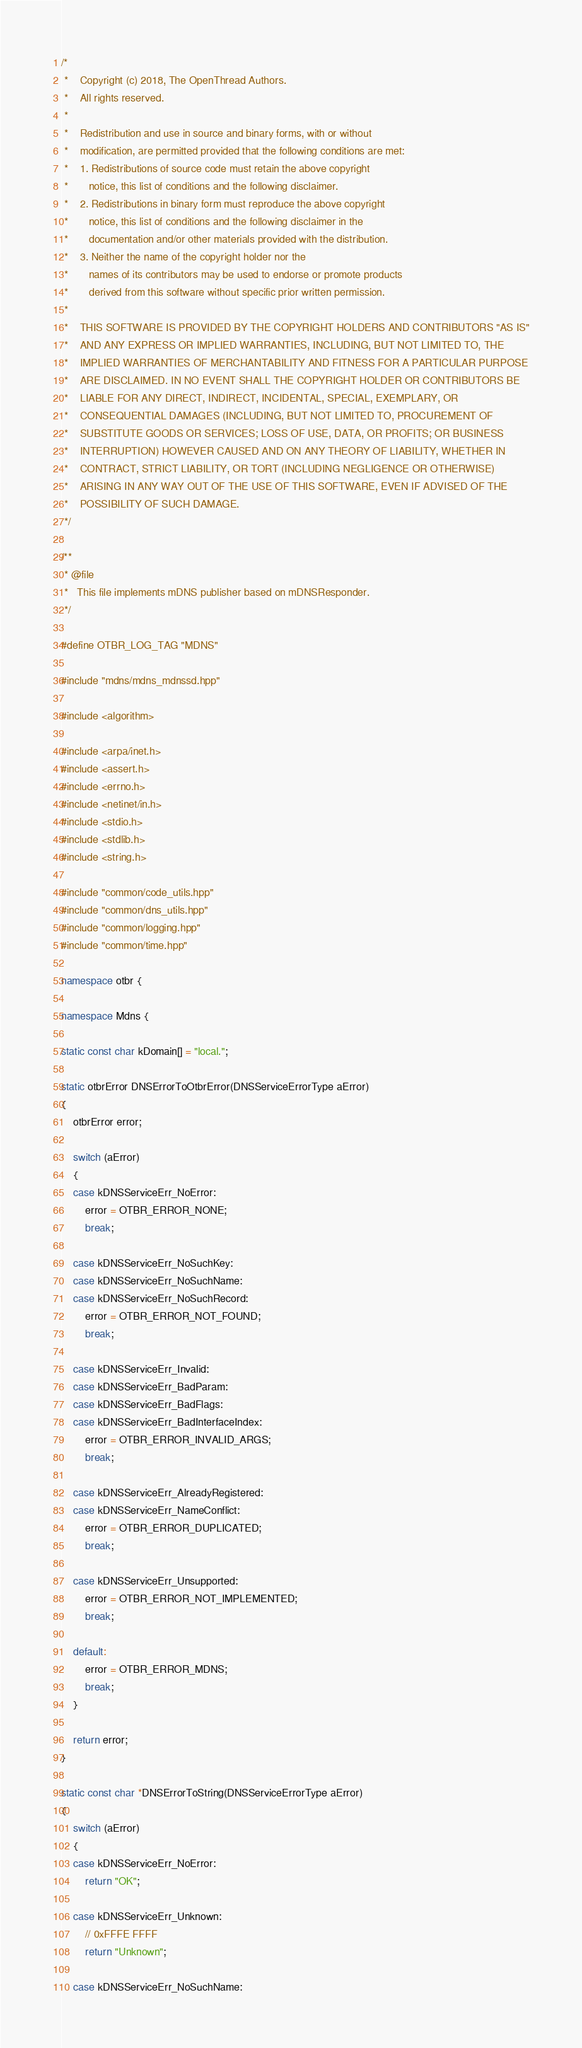<code> <loc_0><loc_0><loc_500><loc_500><_C++_>/*
 *    Copyright (c) 2018, The OpenThread Authors.
 *    All rights reserved.
 *
 *    Redistribution and use in source and binary forms, with or without
 *    modification, are permitted provided that the following conditions are met:
 *    1. Redistributions of source code must retain the above copyright
 *       notice, this list of conditions and the following disclaimer.
 *    2. Redistributions in binary form must reproduce the above copyright
 *       notice, this list of conditions and the following disclaimer in the
 *       documentation and/or other materials provided with the distribution.
 *    3. Neither the name of the copyright holder nor the
 *       names of its contributors may be used to endorse or promote products
 *       derived from this software without specific prior written permission.
 *
 *    THIS SOFTWARE IS PROVIDED BY THE COPYRIGHT HOLDERS AND CONTRIBUTORS "AS IS"
 *    AND ANY EXPRESS OR IMPLIED WARRANTIES, INCLUDING, BUT NOT LIMITED TO, THE
 *    IMPLIED WARRANTIES OF MERCHANTABILITY AND FITNESS FOR A PARTICULAR PURPOSE
 *    ARE DISCLAIMED. IN NO EVENT SHALL THE COPYRIGHT HOLDER OR CONTRIBUTORS BE
 *    LIABLE FOR ANY DIRECT, INDIRECT, INCIDENTAL, SPECIAL, EXEMPLARY, OR
 *    CONSEQUENTIAL DAMAGES (INCLUDING, BUT NOT LIMITED TO, PROCUREMENT OF
 *    SUBSTITUTE GOODS OR SERVICES; LOSS OF USE, DATA, OR PROFITS; OR BUSINESS
 *    INTERRUPTION) HOWEVER CAUSED AND ON ANY THEORY OF LIABILITY, WHETHER IN
 *    CONTRACT, STRICT LIABILITY, OR TORT (INCLUDING NEGLIGENCE OR OTHERWISE)
 *    ARISING IN ANY WAY OUT OF THE USE OF THIS SOFTWARE, EVEN IF ADVISED OF THE
 *    POSSIBILITY OF SUCH DAMAGE.
 */

/**
 * @file
 *   This file implements mDNS publisher based on mDNSResponder.
 */

#define OTBR_LOG_TAG "MDNS"

#include "mdns/mdns_mdnssd.hpp"

#include <algorithm>

#include <arpa/inet.h>
#include <assert.h>
#include <errno.h>
#include <netinet/in.h>
#include <stdio.h>
#include <stdlib.h>
#include <string.h>

#include "common/code_utils.hpp"
#include "common/dns_utils.hpp"
#include "common/logging.hpp"
#include "common/time.hpp"

namespace otbr {

namespace Mdns {

static const char kDomain[] = "local.";

static otbrError DNSErrorToOtbrError(DNSServiceErrorType aError)
{
    otbrError error;

    switch (aError)
    {
    case kDNSServiceErr_NoError:
        error = OTBR_ERROR_NONE;
        break;

    case kDNSServiceErr_NoSuchKey:
    case kDNSServiceErr_NoSuchName:
    case kDNSServiceErr_NoSuchRecord:
        error = OTBR_ERROR_NOT_FOUND;
        break;

    case kDNSServiceErr_Invalid:
    case kDNSServiceErr_BadParam:
    case kDNSServiceErr_BadFlags:
    case kDNSServiceErr_BadInterfaceIndex:
        error = OTBR_ERROR_INVALID_ARGS;
        break;

    case kDNSServiceErr_AlreadyRegistered:
    case kDNSServiceErr_NameConflict:
        error = OTBR_ERROR_DUPLICATED;
        break;

    case kDNSServiceErr_Unsupported:
        error = OTBR_ERROR_NOT_IMPLEMENTED;
        break;

    default:
        error = OTBR_ERROR_MDNS;
        break;
    }

    return error;
}

static const char *DNSErrorToString(DNSServiceErrorType aError)
{
    switch (aError)
    {
    case kDNSServiceErr_NoError:
        return "OK";

    case kDNSServiceErr_Unknown:
        // 0xFFFE FFFF
        return "Unknown";

    case kDNSServiceErr_NoSuchName:</code> 